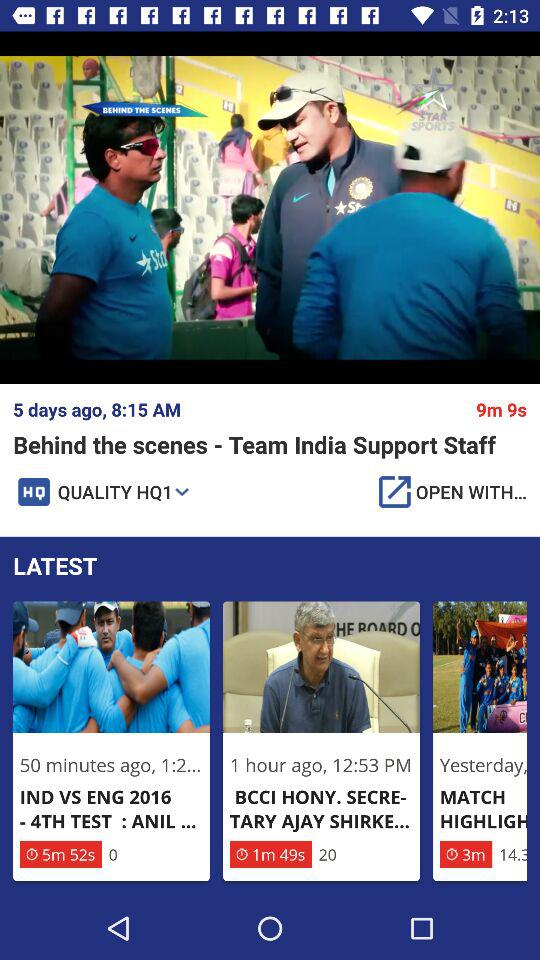How long ago was the video of "BCCI HONY. SECRETARY AJAY SHIRKE" posted? The video was posted 1 hour ago. 